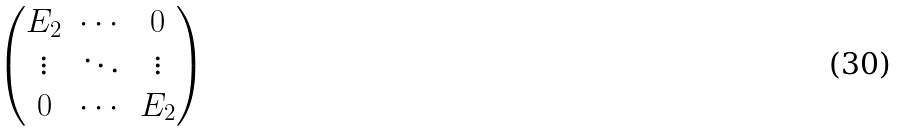Convert formula to latex. <formula><loc_0><loc_0><loc_500><loc_500>\begin{pmatrix} E _ { 2 } & \cdots & 0 \\ \vdots & \ddots & \vdots \\ 0 & \cdots & E _ { 2 } \end{pmatrix}</formula> 